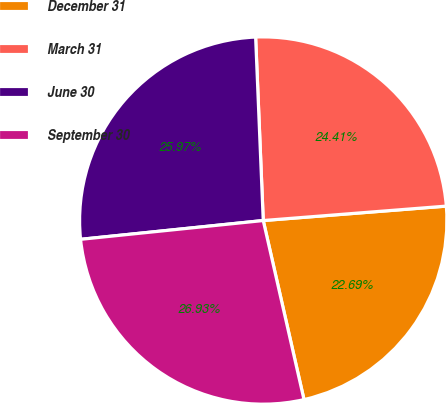Convert chart to OTSL. <chart><loc_0><loc_0><loc_500><loc_500><pie_chart><fcel>December 31<fcel>March 31<fcel>June 30<fcel>September 30<nl><fcel>22.69%<fcel>24.41%<fcel>25.97%<fcel>26.93%<nl></chart> 